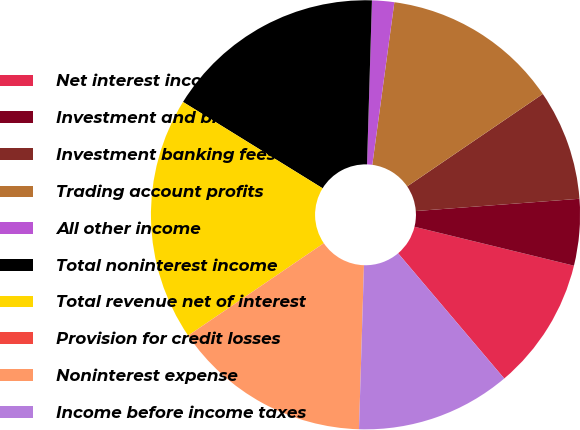<chart> <loc_0><loc_0><loc_500><loc_500><pie_chart><fcel>Net interest income (FTE<fcel>Investment and brokerage<fcel>Investment banking fees<fcel>Trading account profits<fcel>All other income<fcel>Total noninterest income<fcel>Total revenue net of interest<fcel>Provision for credit losses<fcel>Noninterest expense<fcel>Income before income taxes<nl><fcel>10.0%<fcel>5.0%<fcel>8.33%<fcel>13.33%<fcel>1.67%<fcel>16.66%<fcel>18.33%<fcel>0.0%<fcel>15.0%<fcel>11.67%<nl></chart> 